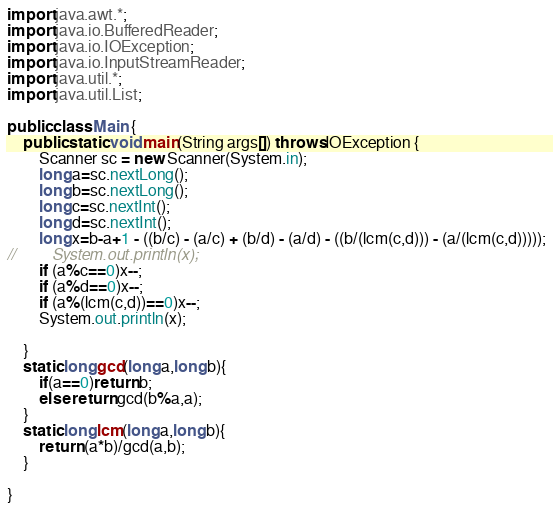<code> <loc_0><loc_0><loc_500><loc_500><_Java_>import java.awt.*;
import java.io.BufferedReader;
import java.io.IOException;
import java.io.InputStreamReader;
import java.util.*;
import java.util.List;

public class Main {
    public static void main(String args[]) throws IOException {
        Scanner sc = new Scanner(System.in);
        long a=sc.nextLong();
        long b=sc.nextLong();
        long c=sc.nextInt();
        long d=sc.nextInt();
        long x=b-a+1 - ((b/c) - (a/c) + (b/d) - (a/d) - ((b/(lcm(c,d))) - (a/(lcm(c,d)))));
//        System.out.println(x);
        if (a%c==0)x--;
        if (a%d==0)x--;
        if (a%(lcm(c,d))==0)x--;
        System.out.println(x);

    }
    static long gcd(long a,long b){
        if(a==0)return b;
        else return gcd(b%a,a);
    }
    static long lcm(long a,long b){
        return (a*b)/gcd(a,b);
    }

}

</code> 